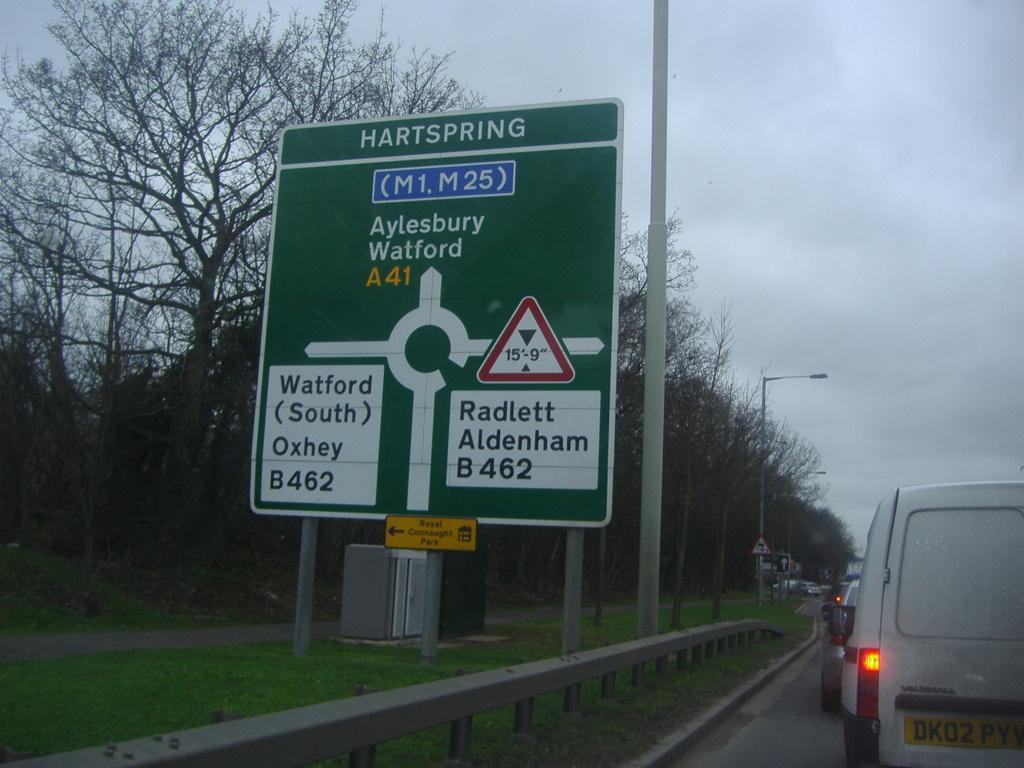Provide a one-sentence caption for the provided image. A green and white sign with Hartspring at the top. 